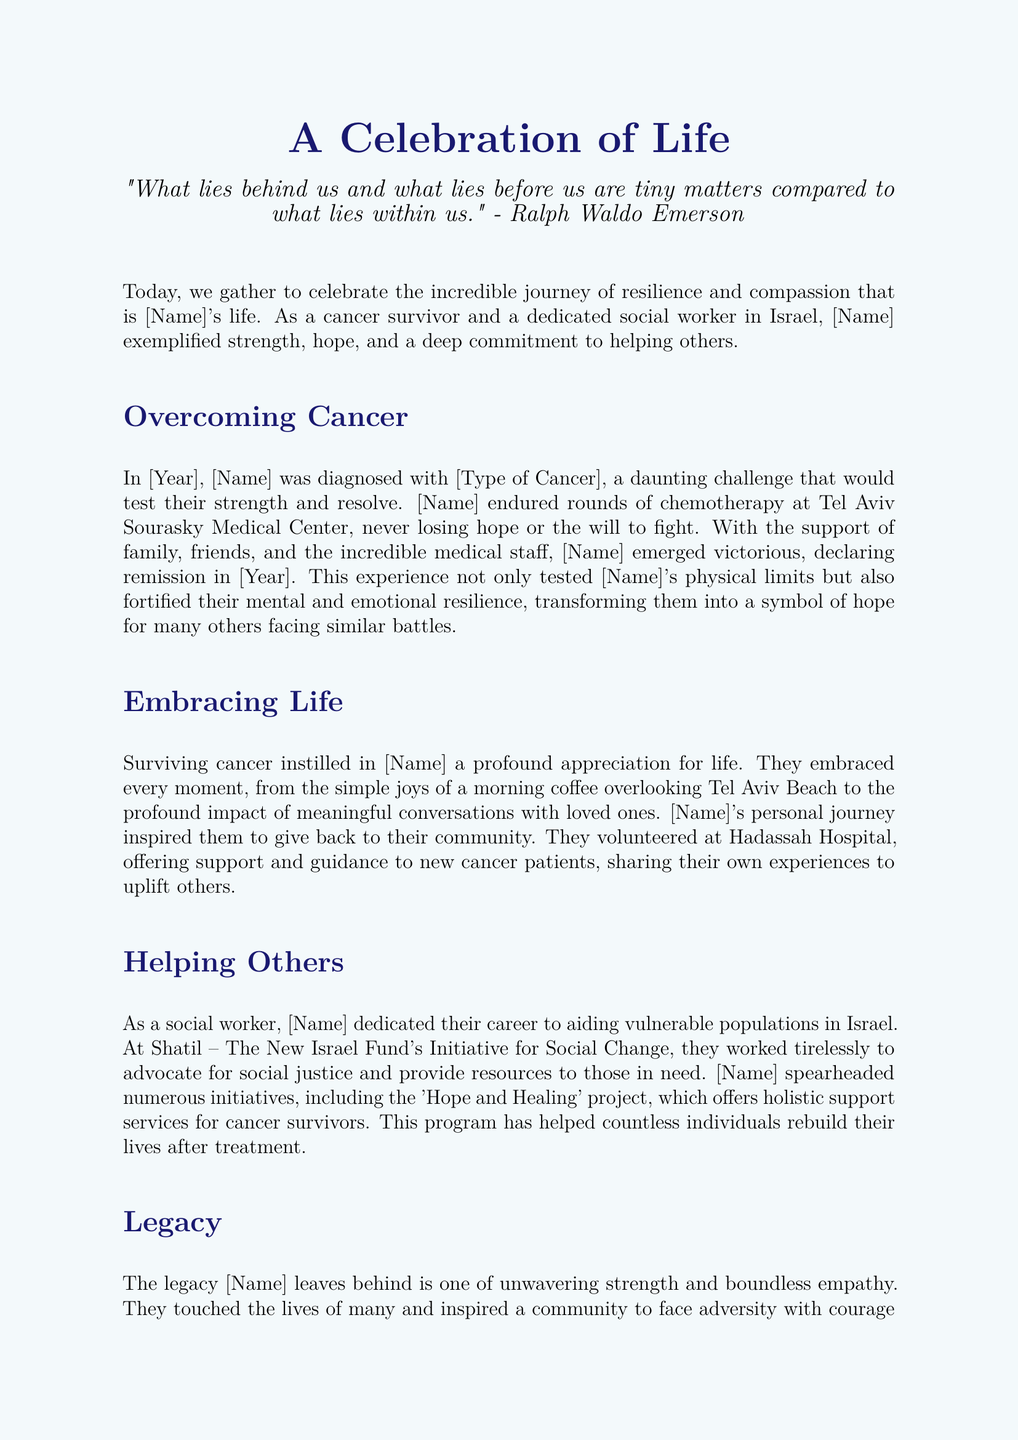What type of cancer did [Name] have? The document mentions [Type of Cancer] as the cancer diagnosis but does not specify an actual name; it’s a placeholder.
Answer: [Type of Cancer] What year was [Name] declared in remission? The text states [Year] as the year of declaring remission, which is also a placeholder.
Answer: [Year] Where did [Name] receive chemotherapy? The document specifies Tel Aviv Sourasky Medical Center as the hospital where [Name] received treatment.
Answer: Tel Aviv Sourasky Medical Center What project did [Name] spearhead? The document highlights the 'Hope and Healing' project as an initiative led by [Name].
Answer: 'Hope and Healing' What is one way [Name] embraced life after cancer? The document provides an example of [Name] enjoying morning coffee overlooking Tel Aviv Beach.
Answer: morning coffee overlooking Tel Aviv Beach What type of support did [Name] offer to new cancer patients? [Name] provided support and guidance, sharing personal experiences to uplift others.
Answer: support and guidance What organization did [Name] work for as a social worker? The text mentions Shatil – The New Israel Fund's Initiative for Social Change as the organization where [Name] worked.
Answer: Shatil – The New Israel Fund's Initiative for Social Change How did [Name] impact their community? The document states that [Name] inspired the community to face adversity with courage and to help one another.
Answer: inspired the community to face adversity What was a key theme of [Name]'s legacy? The document emphasizes unwavering strength and boundless empathy as key themes of [Name]'s legacy.
Answer: unwavering strength and boundless empathy 